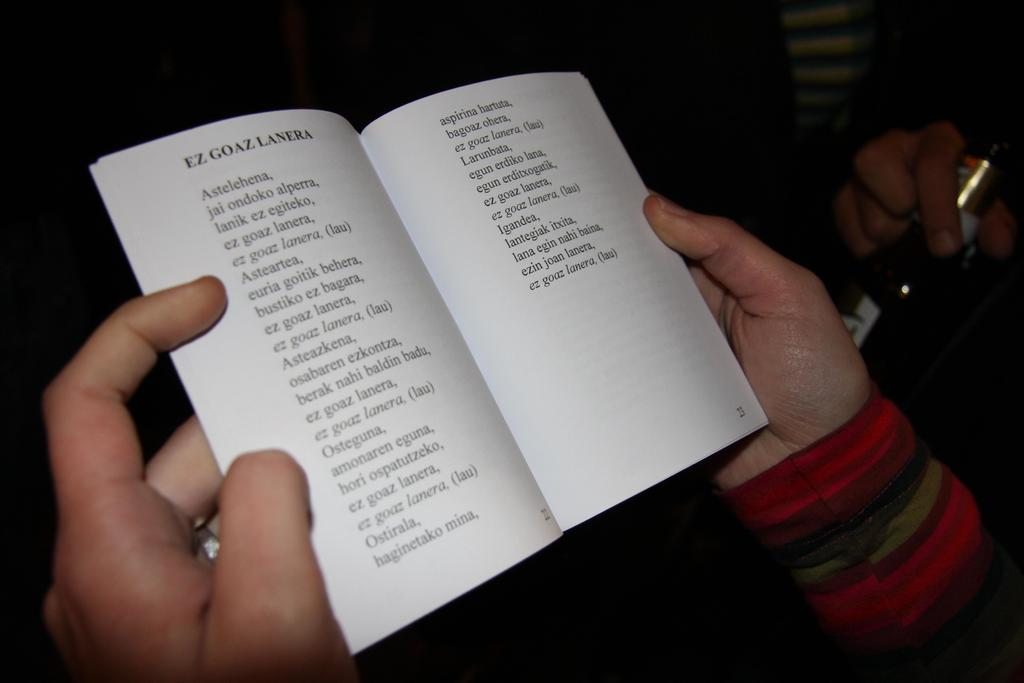<image>
Give a short and clear explanation of the subsequent image. A set of hands on each side of an open book reading EX GOAZ LARENA 